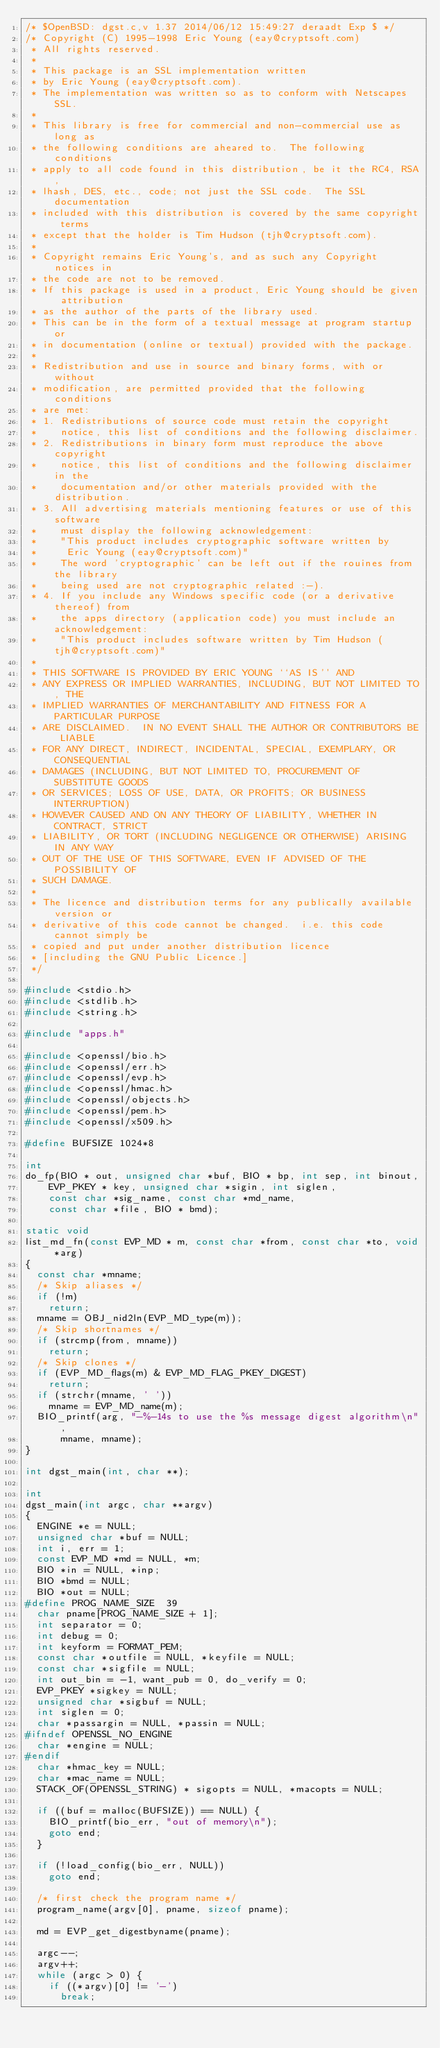Convert code to text. <code><loc_0><loc_0><loc_500><loc_500><_C_>/* $OpenBSD: dgst.c,v 1.37 2014/06/12 15:49:27 deraadt Exp $ */
/* Copyright (C) 1995-1998 Eric Young (eay@cryptsoft.com)
 * All rights reserved.
 *
 * This package is an SSL implementation written
 * by Eric Young (eay@cryptsoft.com).
 * The implementation was written so as to conform with Netscapes SSL.
 *
 * This library is free for commercial and non-commercial use as long as
 * the following conditions are aheared to.  The following conditions
 * apply to all code found in this distribution, be it the RC4, RSA,
 * lhash, DES, etc., code; not just the SSL code.  The SSL documentation
 * included with this distribution is covered by the same copyright terms
 * except that the holder is Tim Hudson (tjh@cryptsoft.com).
 *
 * Copyright remains Eric Young's, and as such any Copyright notices in
 * the code are not to be removed.
 * If this package is used in a product, Eric Young should be given attribution
 * as the author of the parts of the library used.
 * This can be in the form of a textual message at program startup or
 * in documentation (online or textual) provided with the package.
 *
 * Redistribution and use in source and binary forms, with or without
 * modification, are permitted provided that the following conditions
 * are met:
 * 1. Redistributions of source code must retain the copyright
 *    notice, this list of conditions and the following disclaimer.
 * 2. Redistributions in binary form must reproduce the above copyright
 *    notice, this list of conditions and the following disclaimer in the
 *    documentation and/or other materials provided with the distribution.
 * 3. All advertising materials mentioning features or use of this software
 *    must display the following acknowledgement:
 *    "This product includes cryptographic software written by
 *     Eric Young (eay@cryptsoft.com)"
 *    The word 'cryptographic' can be left out if the rouines from the library
 *    being used are not cryptographic related :-).
 * 4. If you include any Windows specific code (or a derivative thereof) from
 *    the apps directory (application code) you must include an acknowledgement:
 *    "This product includes software written by Tim Hudson (tjh@cryptsoft.com)"
 *
 * THIS SOFTWARE IS PROVIDED BY ERIC YOUNG ``AS IS'' AND
 * ANY EXPRESS OR IMPLIED WARRANTIES, INCLUDING, BUT NOT LIMITED TO, THE
 * IMPLIED WARRANTIES OF MERCHANTABILITY AND FITNESS FOR A PARTICULAR PURPOSE
 * ARE DISCLAIMED.  IN NO EVENT SHALL THE AUTHOR OR CONTRIBUTORS BE LIABLE
 * FOR ANY DIRECT, INDIRECT, INCIDENTAL, SPECIAL, EXEMPLARY, OR CONSEQUENTIAL
 * DAMAGES (INCLUDING, BUT NOT LIMITED TO, PROCUREMENT OF SUBSTITUTE GOODS
 * OR SERVICES; LOSS OF USE, DATA, OR PROFITS; OR BUSINESS INTERRUPTION)
 * HOWEVER CAUSED AND ON ANY THEORY OF LIABILITY, WHETHER IN CONTRACT, STRICT
 * LIABILITY, OR TORT (INCLUDING NEGLIGENCE OR OTHERWISE) ARISING IN ANY WAY
 * OUT OF THE USE OF THIS SOFTWARE, EVEN IF ADVISED OF THE POSSIBILITY OF
 * SUCH DAMAGE.
 *
 * The licence and distribution terms for any publically available version or
 * derivative of this code cannot be changed.  i.e. this code cannot simply be
 * copied and put under another distribution licence
 * [including the GNU Public Licence.]
 */

#include <stdio.h>
#include <stdlib.h>
#include <string.h>

#include "apps.h"

#include <openssl/bio.h>
#include <openssl/err.h>
#include <openssl/evp.h>
#include <openssl/hmac.h>
#include <openssl/objects.h>
#include <openssl/pem.h>
#include <openssl/x509.h>

#define BUFSIZE	1024*8

int
do_fp(BIO * out, unsigned char *buf, BIO * bp, int sep, int binout,
    EVP_PKEY * key, unsigned char *sigin, int siglen,
    const char *sig_name, const char *md_name,
    const char *file, BIO * bmd);

static void
list_md_fn(const EVP_MD * m, const char *from, const char *to, void *arg)
{
	const char *mname;
	/* Skip aliases */
	if (!m)
		return;
	mname = OBJ_nid2ln(EVP_MD_type(m));
	/* Skip shortnames */
	if (strcmp(from, mname))
		return;
	/* Skip clones */
	if (EVP_MD_flags(m) & EVP_MD_FLAG_PKEY_DIGEST)
		return;
	if (strchr(mname, ' '))
		mname = EVP_MD_name(m);
	BIO_printf(arg, "-%-14s to use the %s message digest algorithm\n",
	    mname, mname);
}

int dgst_main(int, char **);

int
dgst_main(int argc, char **argv)
{
	ENGINE *e = NULL;
	unsigned char *buf = NULL;
	int i, err = 1;
	const EVP_MD *md = NULL, *m;
	BIO *in = NULL, *inp;
	BIO *bmd = NULL;
	BIO *out = NULL;
#define PROG_NAME_SIZE  39
	char pname[PROG_NAME_SIZE + 1];
	int separator = 0;
	int debug = 0;
	int keyform = FORMAT_PEM;
	const char *outfile = NULL, *keyfile = NULL;
	const char *sigfile = NULL;
	int out_bin = -1, want_pub = 0, do_verify = 0;
	EVP_PKEY *sigkey = NULL;
	unsigned char *sigbuf = NULL;
	int siglen = 0;
	char *passargin = NULL, *passin = NULL;
#ifndef OPENSSL_NO_ENGINE
	char *engine = NULL;
#endif
	char *hmac_key = NULL;
	char *mac_name = NULL;
	STACK_OF(OPENSSL_STRING) * sigopts = NULL, *macopts = NULL;

	if ((buf = malloc(BUFSIZE)) == NULL) {
		BIO_printf(bio_err, "out of memory\n");
		goto end;
	}

	if (!load_config(bio_err, NULL))
		goto end;

	/* first check the program name */
	program_name(argv[0], pname, sizeof pname);

	md = EVP_get_digestbyname(pname);

	argc--;
	argv++;
	while (argc > 0) {
		if ((*argv)[0] != '-')
			break;</code> 